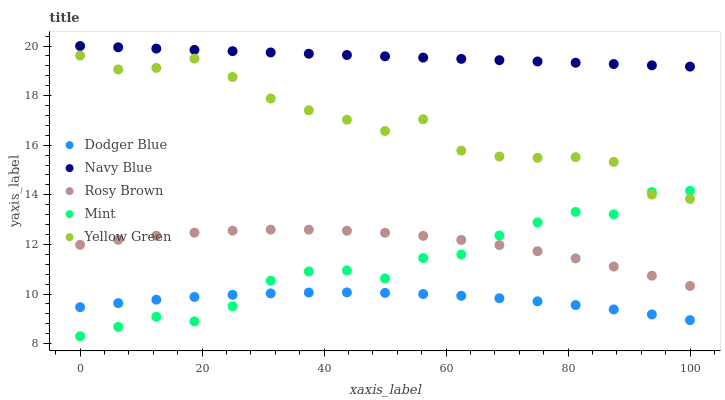Does Dodger Blue have the minimum area under the curve?
Answer yes or no. Yes. Does Navy Blue have the maximum area under the curve?
Answer yes or no. Yes. Does Rosy Brown have the minimum area under the curve?
Answer yes or no. No. Does Rosy Brown have the maximum area under the curve?
Answer yes or no. No. Is Navy Blue the smoothest?
Answer yes or no. Yes. Is Yellow Green the roughest?
Answer yes or no. Yes. Is Rosy Brown the smoothest?
Answer yes or no. No. Is Rosy Brown the roughest?
Answer yes or no. No. Does Mint have the lowest value?
Answer yes or no. Yes. Does Rosy Brown have the lowest value?
Answer yes or no. No. Does Navy Blue have the highest value?
Answer yes or no. Yes. Does Rosy Brown have the highest value?
Answer yes or no. No. Is Yellow Green less than Navy Blue?
Answer yes or no. Yes. Is Rosy Brown greater than Dodger Blue?
Answer yes or no. Yes. Does Mint intersect Dodger Blue?
Answer yes or no. Yes. Is Mint less than Dodger Blue?
Answer yes or no. No. Is Mint greater than Dodger Blue?
Answer yes or no. No. Does Yellow Green intersect Navy Blue?
Answer yes or no. No. 